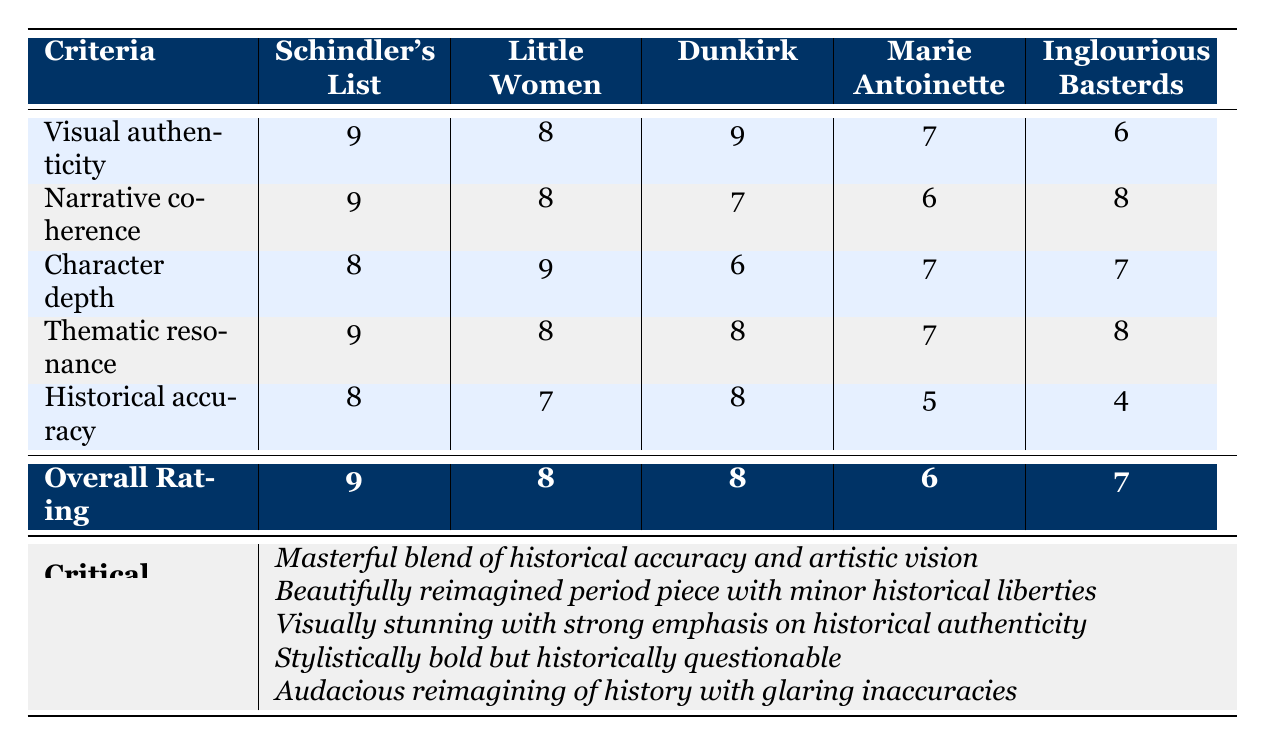What is the artistic merit score for Visual authenticity in Dunkirk? The score for Dunkirk under Visual authenticity is clearly indicated in the table, where Dunkirk has a score of 9.
Answer: 9 Which film has the highest score for Narrative coherence? By comparing the scores across the column for Narrative coherence, Schindler's List and Little Women both have the highest score of 9.
Answer: Schindler's List and Little Women Is Marie Antoinette rated lower for Historical accuracy than Inglourious Basterds? Marie Antoinette has a score of 5 for Historical accuracy, while Inglourious Basterds has a lower score of 4, which means Marie Antoinette is rated higher.
Answer: No What is the average score for Character depth across all films? To find the average, sum all the Character depth scores (8 + 9 + 6 + 7 + 7 = 37) and divide by the number of films (5). The average score is 37/5 = 7.4.
Answer: 7.4 Which film has the lowest score for Thematic resonance? By looking at the scores in the Thematic resonance row, Marie Antoinette has the lowest score of 7.
Answer: Marie Antoinette How many filmmakers received an overall rating of 8 or higher? According to the overall ratings listed at the bottom, two films—Schindler's List and Little Women—received ratings of 9 and 8 respectively. Therefore, the filmmakers for these films also received ratings of 8 or higher.
Answer: 3 Which film is assessed as having a "masterful blend of historical accuracy and artistic vision"? The critical assessment for Schindler's List states it is a "masterful blend of historical accuracy and artistic vision."
Answer: Schindler's List Which criteria did Inglourious Basterds score the lowest in? Upon examining the criteria for Inglourious Basterds, the Historical accuracy score of 4 is the lowest compared to others.
Answer: Historical accuracy 